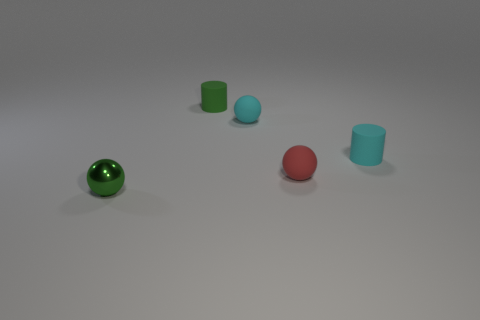Is there any other thing that has the same material as the green ball?
Ensure brevity in your answer.  No. There is a small metallic object; does it have the same color as the matte ball that is to the left of the red matte thing?
Provide a short and direct response. No. There is a small object that is left of the cyan sphere and behind the small cyan rubber cylinder; what is its shape?
Your answer should be very brief. Cylinder. Is the number of large brown things less than the number of rubber cylinders?
Offer a terse response. Yes. Are there any purple shiny objects?
Offer a very short reply. No. How many other objects are the same size as the red thing?
Ensure brevity in your answer.  4. Are the cyan cylinder and the tiny green thing that is to the right of the green sphere made of the same material?
Keep it short and to the point. Yes. Are there the same number of cyan things that are on the left side of the tiny green cylinder and tiny rubber cylinders that are on the left side of the small red matte thing?
Offer a terse response. No. What is the material of the small green ball?
Your answer should be compact. Metal. The other matte cylinder that is the same size as the cyan cylinder is what color?
Your answer should be very brief. Green. 